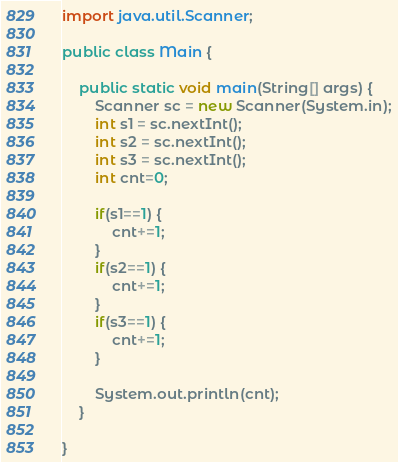<code> <loc_0><loc_0><loc_500><loc_500><_Java_>import java.util.Scanner;

public class Main {

	public static void main(String[] args) {
		Scanner sc = new Scanner(System.in);
		int s1 = sc.nextInt();
		int s2 = sc.nextInt();
		int s3 = sc.nextInt();
		int cnt=0;
		
		if(s1==1) {
			cnt+=1;
		}
		if(s2==1) {
			cnt+=1;
		}
		if(s3==1) {
			cnt+=1;
		}
		
		System.out.println(cnt);
	}

}
</code> 